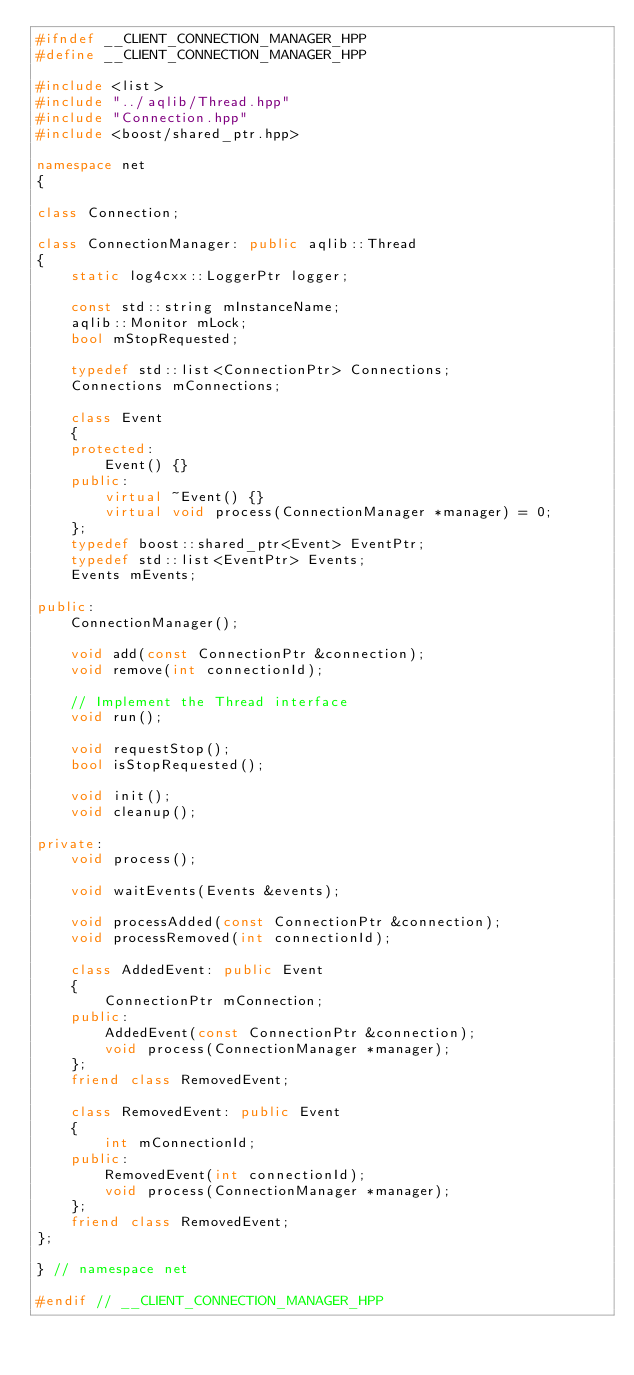<code> <loc_0><loc_0><loc_500><loc_500><_C++_>#ifndef __CLIENT_CONNECTION_MANAGER_HPP
#define __CLIENT_CONNECTION_MANAGER_HPP

#include <list>
#include "../aqlib/Thread.hpp"
#include "Connection.hpp"
#include <boost/shared_ptr.hpp>

namespace net
{

class Connection;

class ConnectionManager: public aqlib::Thread
{
    static log4cxx::LoggerPtr logger;
    
    const std::string mInstanceName;
    aqlib::Monitor mLock;
    bool mStopRequested;    
    
    typedef std::list<ConnectionPtr> Connections;
    Connections mConnections;
    
    class Event 
    {
    protected:
        Event() {}
    public:
        virtual ~Event() {}
        virtual void process(ConnectionManager *manager) = 0;
    };
    typedef boost::shared_ptr<Event> EventPtr;
    typedef std::list<EventPtr> Events;
    Events mEvents;

public:
    ConnectionManager();
    
    void add(const ConnectionPtr &connection);
    void remove(int connectionId);
    
    // Implement the Thread interface
    void run();
    
    void requestStop();
    bool isStopRequested();
    
    void init();
    void cleanup();
    
private:
    void process();
    
    void waitEvents(Events &events);
    
    void processAdded(const ConnectionPtr &connection);
    void processRemoved(int connectionId);
    
    class AddedEvent: public Event
    {
        ConnectionPtr mConnection;
    public:
        AddedEvent(const ConnectionPtr &connection);
        void process(ConnectionManager *manager);
    };
    friend class RemovedEvent;
    
    class RemovedEvent: public Event
    {
        int mConnectionId;
    public:
        RemovedEvent(int connectionId);
        void process(ConnectionManager *manager);
    };
    friend class RemovedEvent;    
};

} // namespace net

#endif // __CLIENT_CONNECTION_MANAGER_HPP
</code> 